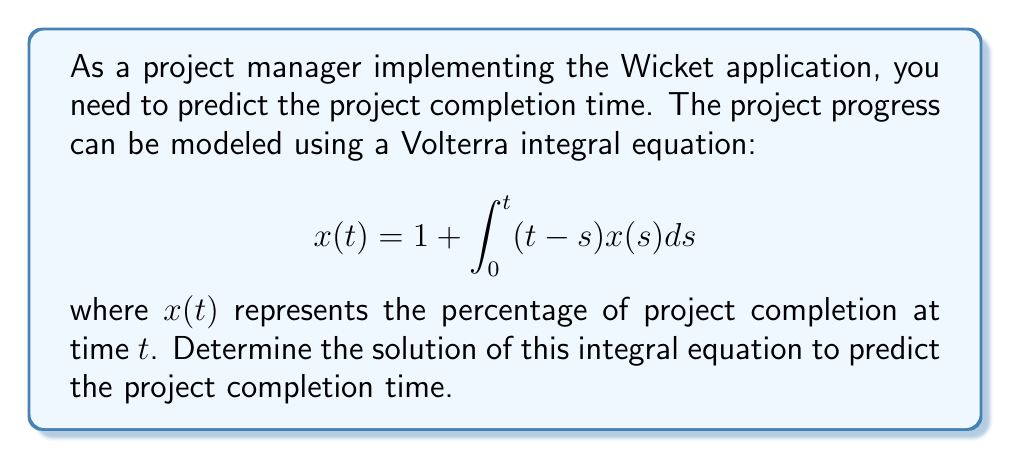Help me with this question. To solve this Volterra integral equation, we'll use the method of successive approximations:

1) Start with the initial approximation $x_0(t) = 1$.

2) Substitute this into the right-hand side of the equation to get the next approximation:

   $$x_1(t) = 1 + \int_0^t (t-s) \cdot 1 ds = 1 + \frac{t^2}{2}$$

3) Continue this process:

   $$x_2(t) = 1 + \int_0^t (t-s) \cdot (1 + \frac{s^2}{2}) ds = 1 + \frac{t^2}{2} + \frac{t^4}{24}$$

   $$x_3(t) = 1 + \int_0^t (t-s) \cdot (1 + \frac{s^2}{2} + \frac{s^4}{24}) ds = 1 + \frac{t^2}{2} + \frac{t^4}{24} + \frac{t^6}{720}$$

4) We can see a pattern forming. The general solution is:

   $$x(t) = 1 + \frac{t^2}{2!} + \frac{t^4}{4!} + \frac{t^6}{6!} + ...$$

5) This series can be recognized as the even terms of the Taylor series for $e^t$:

   $$x(t) = \frac{e^t + e^{-t}}{2} = \cosh(t)$$

6) To find the project completion time, we need to solve:

   $$\cosh(t) = 2$$

   $$t = \cosh^{-1}(2) \approx 1.317$$

Therefore, the project will be completed when $t \approx 1.317$ time units.
Answer: $x(t) = \cosh(t)$; completion time $\approx 1.317$ units 